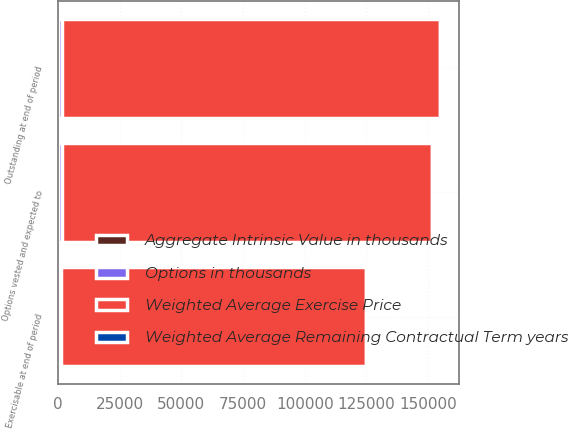Convert chart to OTSL. <chart><loc_0><loc_0><loc_500><loc_500><stacked_bar_chart><ecel><fcel>Outstanding at end of period<fcel>Exercisable at end of period<fcel>Options vested and expected to<nl><fcel>Options in thousands<fcel>1646<fcel>1156<fcel>1594<nl><fcel>Aggregate Intrinsic Value in thousands<fcel>32.09<fcel>18.26<fcel>31.06<nl><fcel>Weighted Average Remaining Contractual Term years<fcel>5.46<fcel>4.36<fcel>5.37<nl><fcel>Weighted Average Exercise Price<fcel>153254<fcel>123592<fcel>150056<nl></chart> 